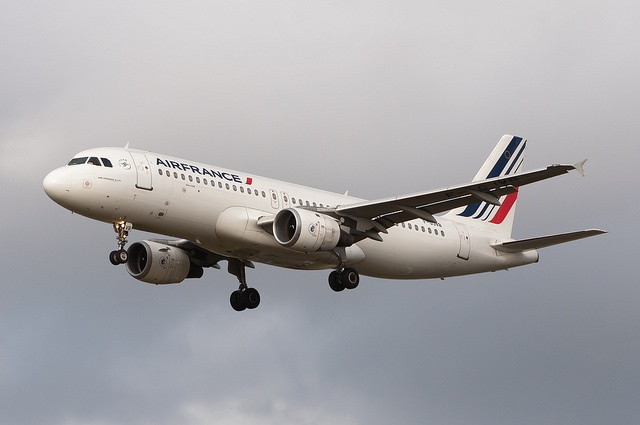Describe the objects in this image and their specific colors. I can see a airplane in lightgray, black, darkgray, and gray tones in this image. 